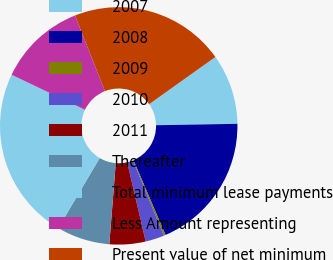Convert chart. <chart><loc_0><loc_0><loc_500><loc_500><pie_chart><fcel>2007<fcel>2008<fcel>2009<fcel>2010<fcel>2011<fcel>Thereafter<fcel>Total minimum lease payments<fcel>Less Amount representing<fcel>Present value of net minimum<nl><fcel>9.58%<fcel>18.82%<fcel>0.24%<fcel>2.57%<fcel>4.91%<fcel>7.24%<fcel>23.58%<fcel>11.91%<fcel>21.15%<nl></chart> 